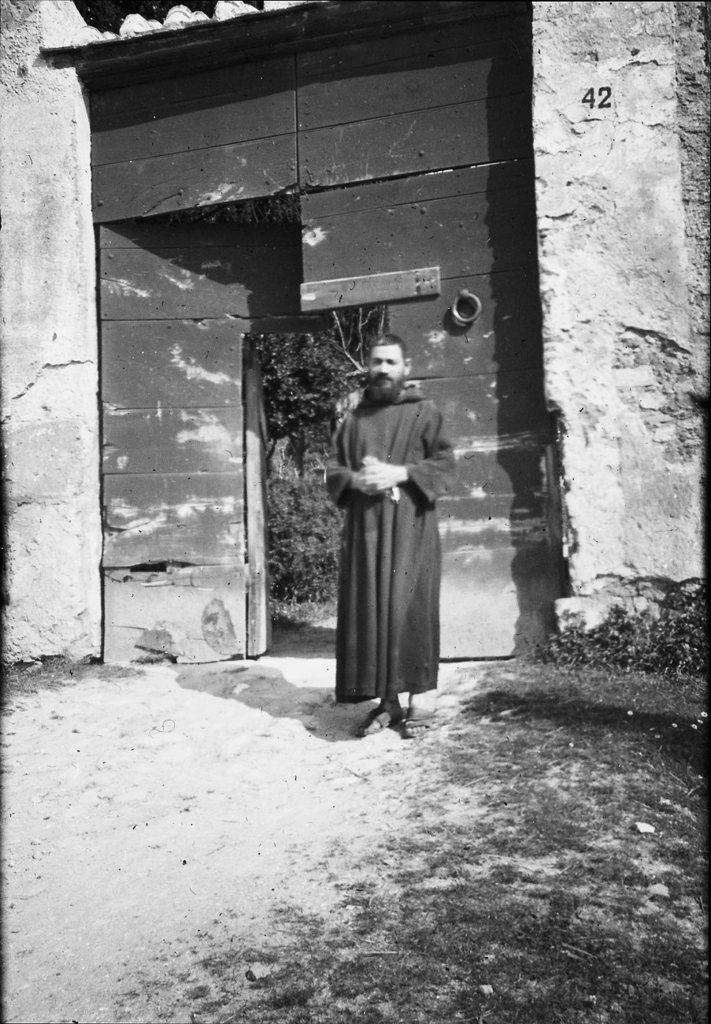What is the color scheme of the image? The image is black and white. What can be seen in the image besides the color scheme? There is a person standing in front of a door. What type of surface is visible at the bottom of the image? Grass is present at the bottom of the image. What type of meat is being prepared on the grill in the image? There is no grill or meat present in the image; it features a person standing in front of a door with a black and white color scheme and grass at the bottom. 